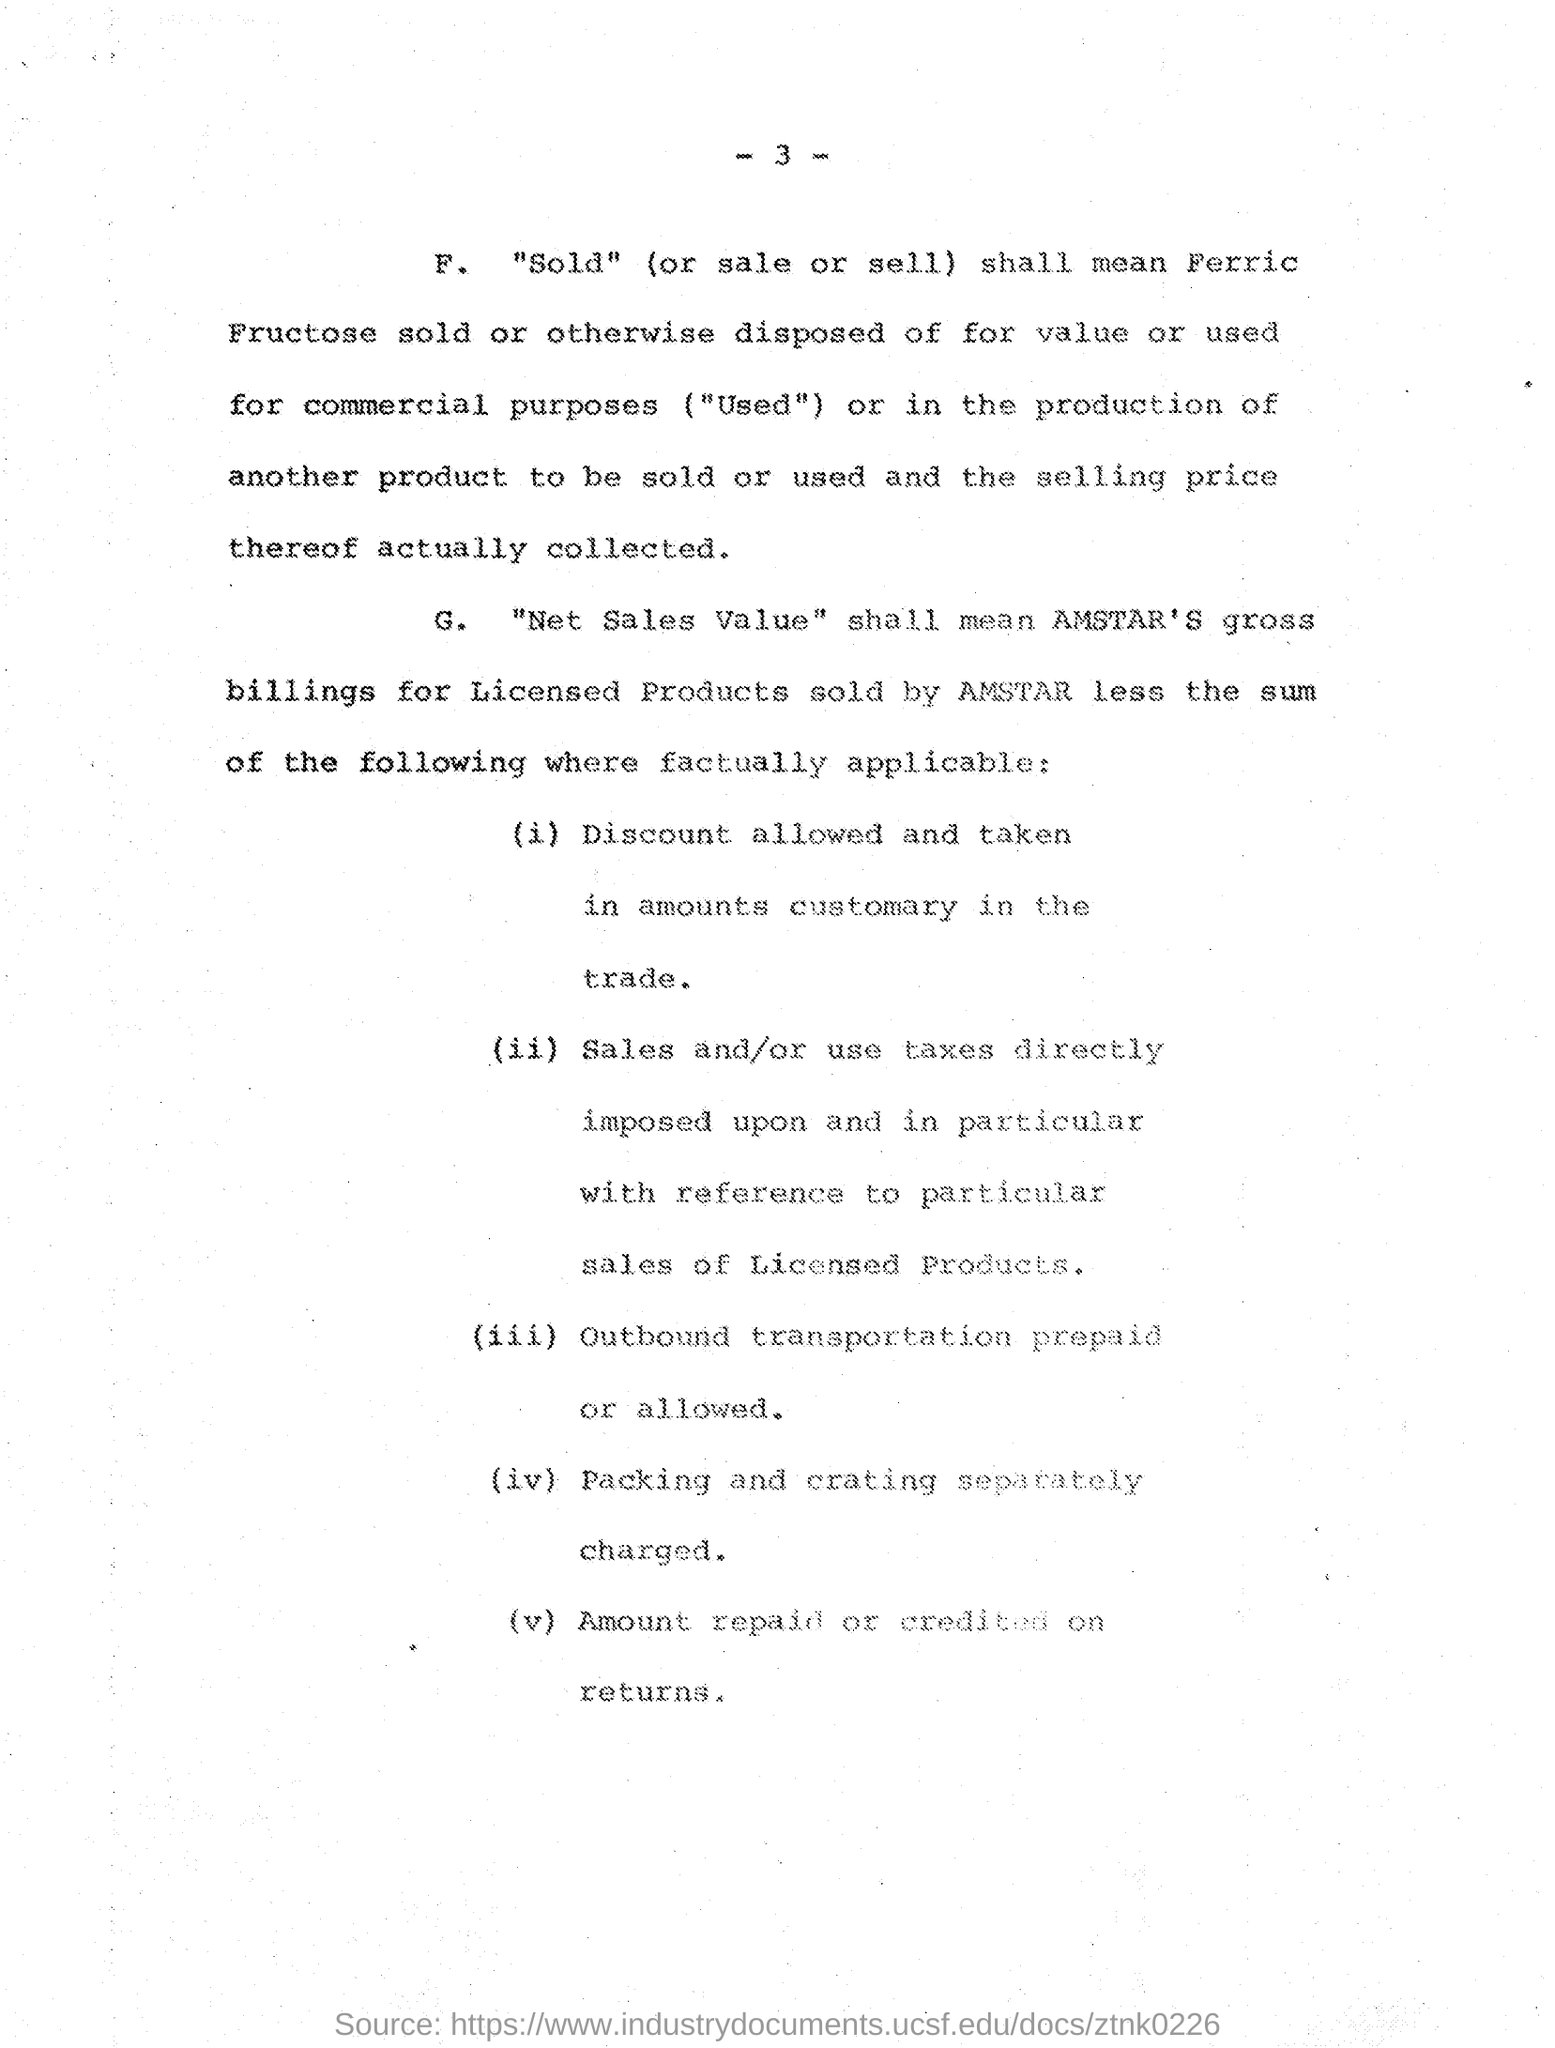Give some essential details in this illustration. For what purpose is packing and crating separately charged? This page number is written at the top, and it is 3. 